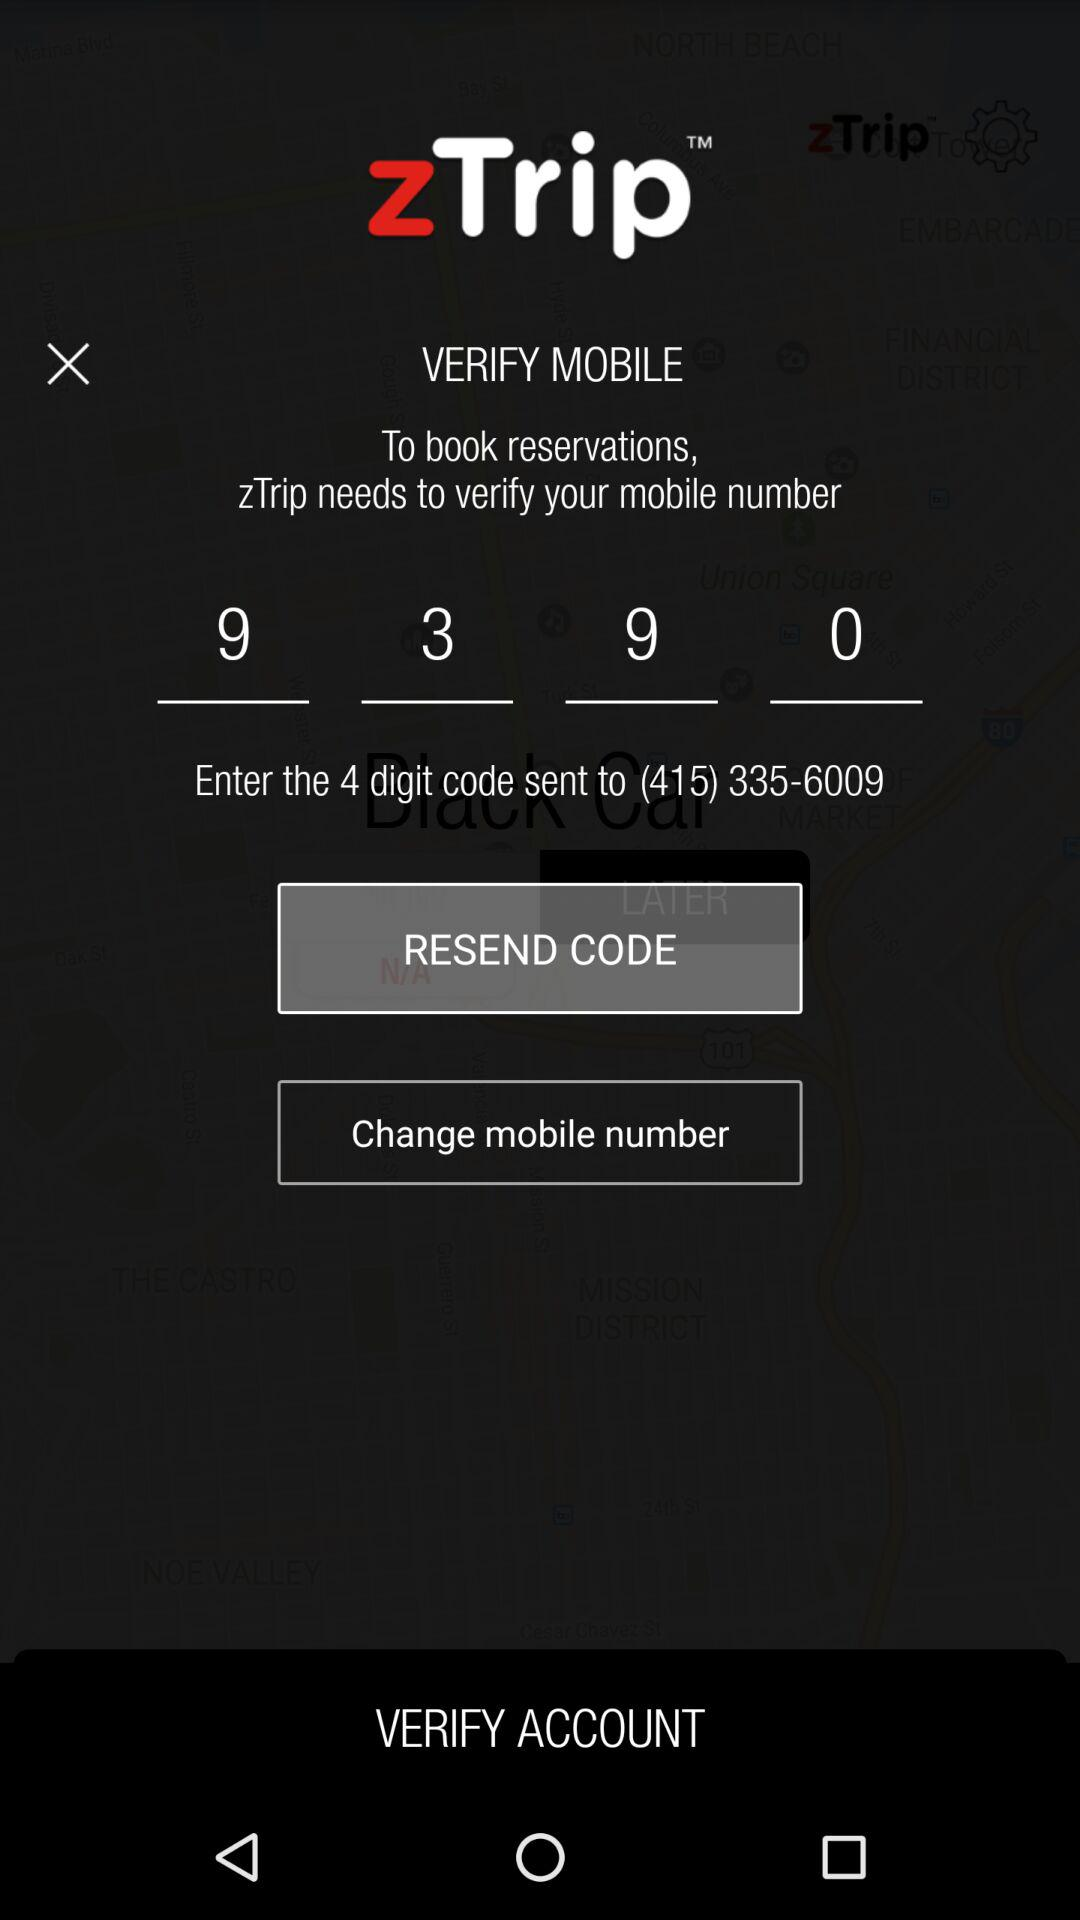How many digits are in the code?
Answer the question using a single word or phrase. 4 